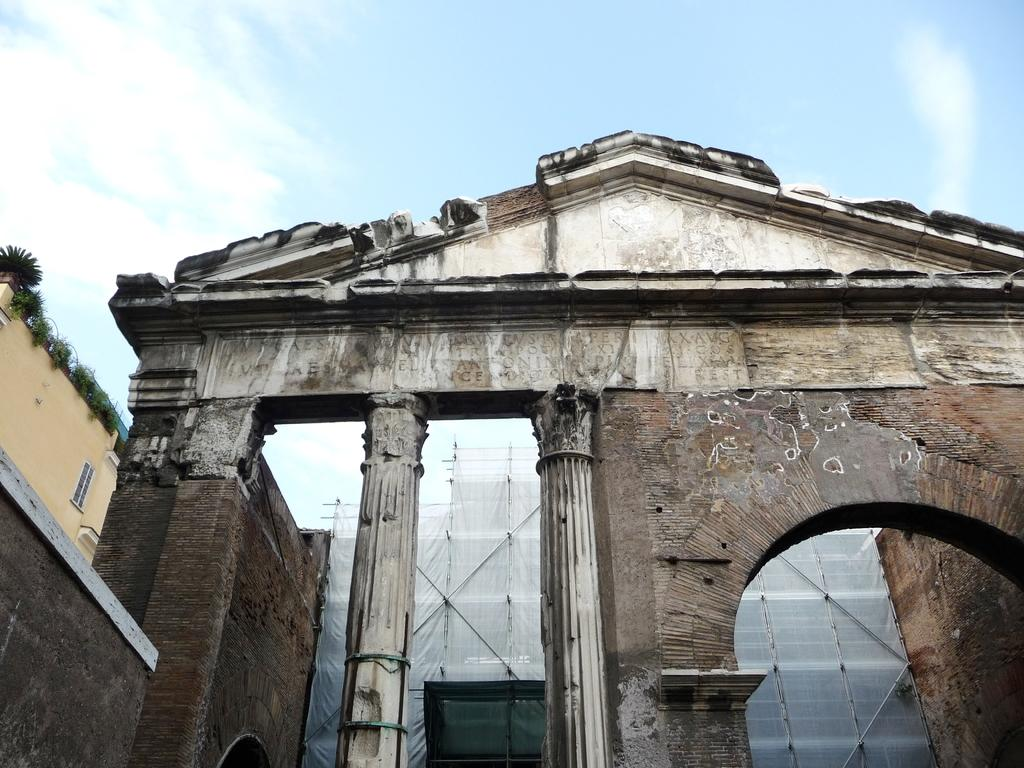What type of structures can be seen in the image? There are buildings in the image. What architectural features are present in the image? There are pillars in the image. Can you describe a specific feature of one of the buildings? There is a window in the image. What can be found on the left side of a building? There are house plants on the left side of a building. What is visible in the background of the image? In the background, there are poles, cloth, and clouds in the sky. How many legs can be seen on the men in the image? There are no men present in the image, so it is not possible to determine the number of legs. What type of gun is visible in the image? There is no gun present in the image. 